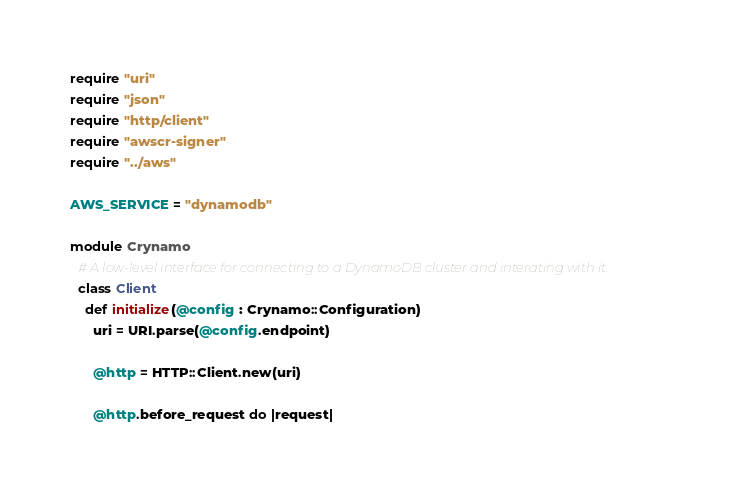Convert code to text. <code><loc_0><loc_0><loc_500><loc_500><_Crystal_>require "uri"
require "json"
require "http/client"
require "awscr-signer"
require "../aws"

AWS_SERVICE = "dynamodb"

module Crynamo
  # A low-level interface for connecting to a DynamoDB cluster and interating with it.
  class Client
    def initialize(@config : Crynamo::Configuration)
      uri = URI.parse(@config.endpoint)

      @http = HTTP::Client.new(uri)

      @http.before_request do |request|</code> 